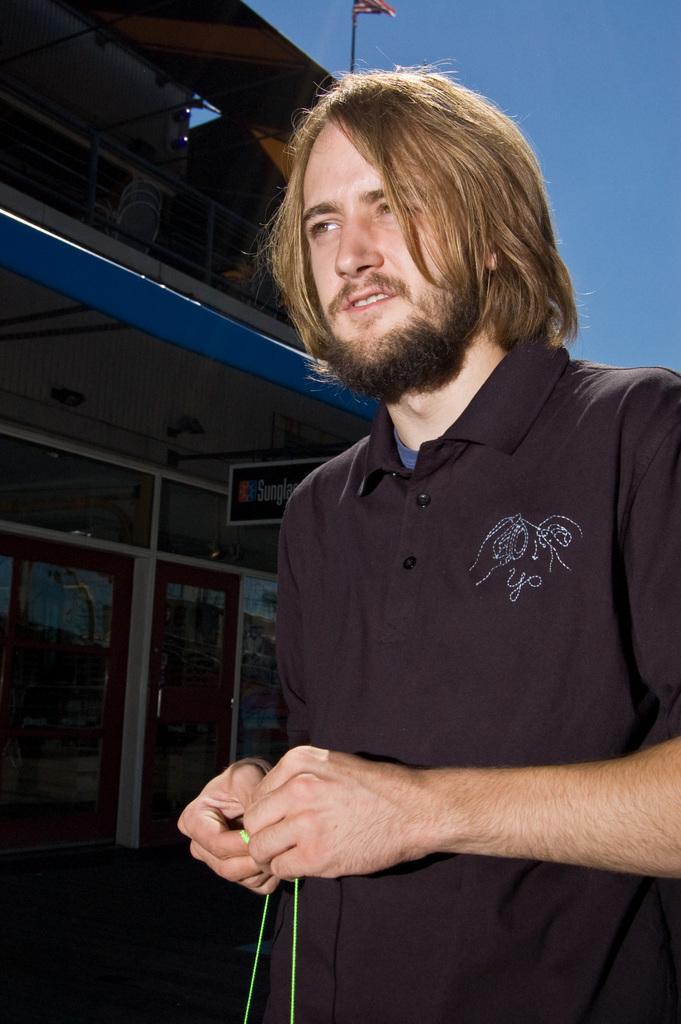Please provide a concise description of this image. In the foreground I can see a man is holding some object in hand. In the background I can see a building, board, flag pole, metal rods, door and the sky. This image is taken may be near the building. 